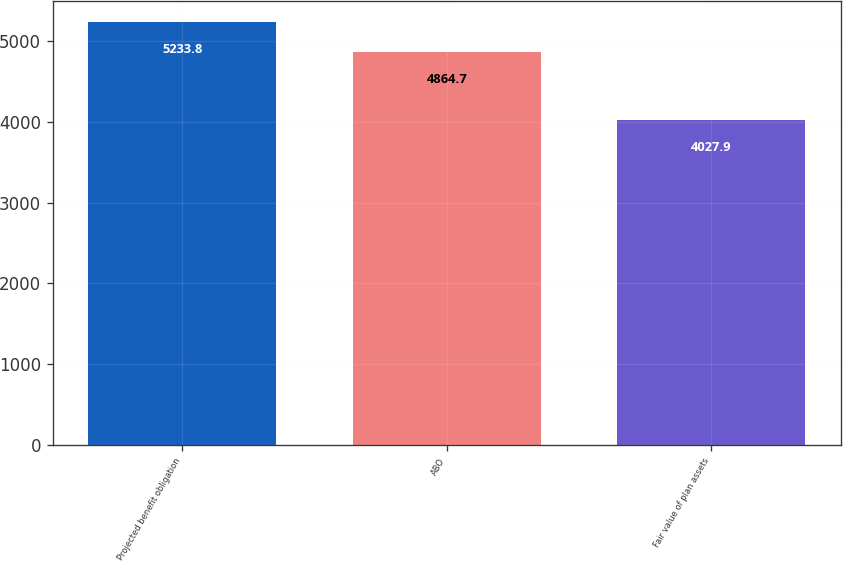Convert chart to OTSL. <chart><loc_0><loc_0><loc_500><loc_500><bar_chart><fcel>Projected benefit obligation<fcel>ABO<fcel>Fair value of plan assets<nl><fcel>5233.8<fcel>4864.7<fcel>4027.9<nl></chart> 